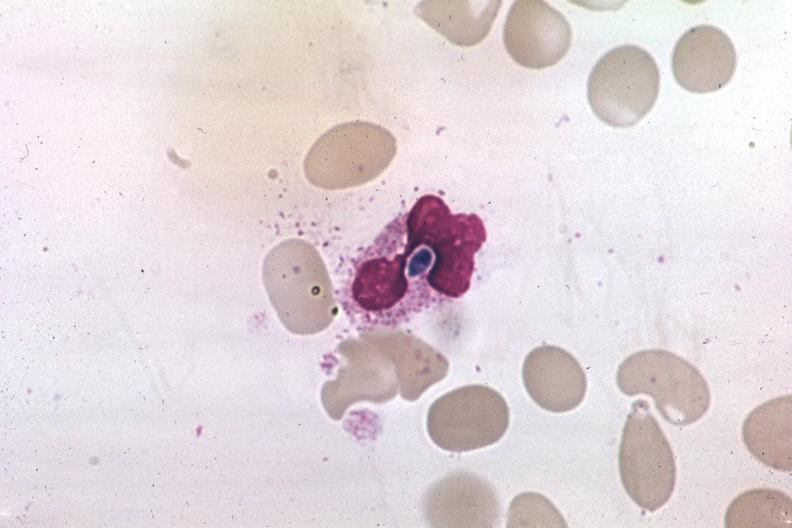s candida in peripheral blood present?
Answer the question using a single word or phrase. Yes 